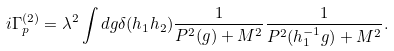<formula> <loc_0><loc_0><loc_500><loc_500>i \Gamma _ { p } ^ { ( 2 ) } = \lambda ^ { 2 } \int d g \delta ( h _ { 1 } h _ { 2 } ) \frac { 1 } { P ^ { 2 } ( g ) + M ^ { 2 } } \frac { 1 } { P ^ { 2 } ( h _ { 1 } ^ { - 1 } g ) + M ^ { 2 } } .</formula> 